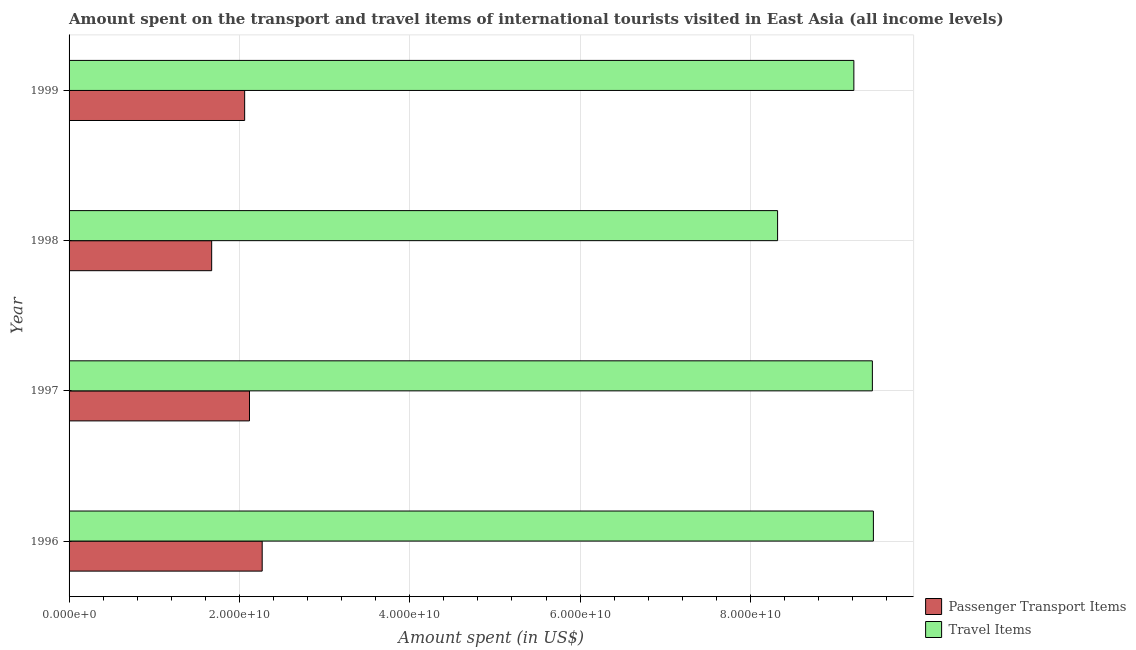How many different coloured bars are there?
Your answer should be compact. 2. How many groups of bars are there?
Make the answer very short. 4. Are the number of bars per tick equal to the number of legend labels?
Provide a succinct answer. Yes. How many bars are there on the 4th tick from the bottom?
Offer a very short reply. 2. What is the amount spent on passenger transport items in 1996?
Offer a very short reply. 2.27e+1. Across all years, what is the maximum amount spent in travel items?
Offer a very short reply. 9.44e+1. Across all years, what is the minimum amount spent in travel items?
Give a very brief answer. 8.32e+1. What is the total amount spent in travel items in the graph?
Provide a short and direct response. 3.64e+11. What is the difference between the amount spent on passenger transport items in 1998 and that in 1999?
Keep it short and to the point. -3.87e+09. What is the difference between the amount spent in travel items in 1998 and the amount spent on passenger transport items in 1997?
Keep it short and to the point. 6.20e+1. What is the average amount spent in travel items per year?
Offer a terse response. 9.10e+1. In the year 1999, what is the difference between the amount spent on passenger transport items and amount spent in travel items?
Provide a succinct answer. -7.15e+1. What is the difference between the highest and the second highest amount spent in travel items?
Provide a short and direct response. 1.20e+08. What is the difference between the highest and the lowest amount spent on passenger transport items?
Give a very brief answer. 5.93e+09. In how many years, is the amount spent on passenger transport items greater than the average amount spent on passenger transport items taken over all years?
Give a very brief answer. 3. What does the 2nd bar from the top in 1996 represents?
Provide a short and direct response. Passenger Transport Items. What does the 2nd bar from the bottom in 1996 represents?
Your response must be concise. Travel Items. Are all the bars in the graph horizontal?
Provide a short and direct response. Yes. How many years are there in the graph?
Give a very brief answer. 4. What is the difference between two consecutive major ticks on the X-axis?
Provide a succinct answer. 2.00e+1. Are the values on the major ticks of X-axis written in scientific E-notation?
Your response must be concise. Yes. How many legend labels are there?
Offer a terse response. 2. How are the legend labels stacked?
Ensure brevity in your answer.  Vertical. What is the title of the graph?
Ensure brevity in your answer.  Amount spent on the transport and travel items of international tourists visited in East Asia (all income levels). Does "RDB nonconcessional" appear as one of the legend labels in the graph?
Your response must be concise. No. What is the label or title of the X-axis?
Provide a short and direct response. Amount spent (in US$). What is the Amount spent (in US$) in Passenger Transport Items in 1996?
Your answer should be compact. 2.27e+1. What is the Amount spent (in US$) of Travel Items in 1996?
Your answer should be compact. 9.44e+1. What is the Amount spent (in US$) in Passenger Transport Items in 1997?
Make the answer very short. 2.12e+1. What is the Amount spent (in US$) of Travel Items in 1997?
Offer a terse response. 9.43e+1. What is the Amount spent (in US$) in Passenger Transport Items in 1998?
Make the answer very short. 1.67e+1. What is the Amount spent (in US$) of Travel Items in 1998?
Provide a short and direct response. 8.32e+1. What is the Amount spent (in US$) of Passenger Transport Items in 1999?
Make the answer very short. 2.06e+1. What is the Amount spent (in US$) in Travel Items in 1999?
Offer a terse response. 9.21e+1. Across all years, what is the maximum Amount spent (in US$) of Passenger Transport Items?
Keep it short and to the point. 2.27e+1. Across all years, what is the maximum Amount spent (in US$) of Travel Items?
Offer a terse response. 9.44e+1. Across all years, what is the minimum Amount spent (in US$) of Passenger Transport Items?
Offer a terse response. 1.67e+1. Across all years, what is the minimum Amount spent (in US$) of Travel Items?
Your answer should be very brief. 8.32e+1. What is the total Amount spent (in US$) in Passenger Transport Items in the graph?
Your answer should be very brief. 8.12e+1. What is the total Amount spent (in US$) of Travel Items in the graph?
Your answer should be very brief. 3.64e+11. What is the difference between the Amount spent (in US$) in Passenger Transport Items in 1996 and that in 1997?
Keep it short and to the point. 1.49e+09. What is the difference between the Amount spent (in US$) of Travel Items in 1996 and that in 1997?
Provide a succinct answer. 1.20e+08. What is the difference between the Amount spent (in US$) in Passenger Transport Items in 1996 and that in 1998?
Offer a very short reply. 5.93e+09. What is the difference between the Amount spent (in US$) in Travel Items in 1996 and that in 1998?
Give a very brief answer. 1.12e+1. What is the difference between the Amount spent (in US$) in Passenger Transport Items in 1996 and that in 1999?
Keep it short and to the point. 2.06e+09. What is the difference between the Amount spent (in US$) of Travel Items in 1996 and that in 1999?
Your response must be concise. 2.29e+09. What is the difference between the Amount spent (in US$) of Passenger Transport Items in 1997 and that in 1998?
Your response must be concise. 4.44e+09. What is the difference between the Amount spent (in US$) of Travel Items in 1997 and that in 1998?
Keep it short and to the point. 1.11e+1. What is the difference between the Amount spent (in US$) of Passenger Transport Items in 1997 and that in 1999?
Provide a short and direct response. 5.68e+08. What is the difference between the Amount spent (in US$) of Travel Items in 1997 and that in 1999?
Ensure brevity in your answer.  2.17e+09. What is the difference between the Amount spent (in US$) of Passenger Transport Items in 1998 and that in 1999?
Give a very brief answer. -3.87e+09. What is the difference between the Amount spent (in US$) of Travel Items in 1998 and that in 1999?
Your response must be concise. -8.95e+09. What is the difference between the Amount spent (in US$) of Passenger Transport Items in 1996 and the Amount spent (in US$) of Travel Items in 1997?
Provide a short and direct response. -7.16e+1. What is the difference between the Amount spent (in US$) in Passenger Transport Items in 1996 and the Amount spent (in US$) in Travel Items in 1998?
Provide a short and direct response. -6.05e+1. What is the difference between the Amount spent (in US$) in Passenger Transport Items in 1996 and the Amount spent (in US$) in Travel Items in 1999?
Your response must be concise. -6.95e+1. What is the difference between the Amount spent (in US$) in Passenger Transport Items in 1997 and the Amount spent (in US$) in Travel Items in 1998?
Provide a succinct answer. -6.20e+1. What is the difference between the Amount spent (in US$) in Passenger Transport Items in 1997 and the Amount spent (in US$) in Travel Items in 1999?
Your answer should be compact. -7.10e+1. What is the difference between the Amount spent (in US$) in Passenger Transport Items in 1998 and the Amount spent (in US$) in Travel Items in 1999?
Your answer should be very brief. -7.54e+1. What is the average Amount spent (in US$) in Passenger Transport Items per year?
Keep it short and to the point. 2.03e+1. What is the average Amount spent (in US$) of Travel Items per year?
Ensure brevity in your answer.  9.10e+1. In the year 1996, what is the difference between the Amount spent (in US$) in Passenger Transport Items and Amount spent (in US$) in Travel Items?
Make the answer very short. -7.18e+1. In the year 1997, what is the difference between the Amount spent (in US$) in Passenger Transport Items and Amount spent (in US$) in Travel Items?
Your response must be concise. -7.31e+1. In the year 1998, what is the difference between the Amount spent (in US$) of Passenger Transport Items and Amount spent (in US$) of Travel Items?
Give a very brief answer. -6.64e+1. In the year 1999, what is the difference between the Amount spent (in US$) of Passenger Transport Items and Amount spent (in US$) of Travel Items?
Offer a terse response. -7.15e+1. What is the ratio of the Amount spent (in US$) of Passenger Transport Items in 1996 to that in 1997?
Provide a short and direct response. 1.07. What is the ratio of the Amount spent (in US$) in Passenger Transport Items in 1996 to that in 1998?
Provide a succinct answer. 1.35. What is the ratio of the Amount spent (in US$) of Travel Items in 1996 to that in 1998?
Give a very brief answer. 1.14. What is the ratio of the Amount spent (in US$) in Passenger Transport Items in 1996 to that in 1999?
Offer a terse response. 1.1. What is the ratio of the Amount spent (in US$) of Travel Items in 1996 to that in 1999?
Your response must be concise. 1.02. What is the ratio of the Amount spent (in US$) of Passenger Transport Items in 1997 to that in 1998?
Give a very brief answer. 1.27. What is the ratio of the Amount spent (in US$) of Travel Items in 1997 to that in 1998?
Offer a terse response. 1.13. What is the ratio of the Amount spent (in US$) of Passenger Transport Items in 1997 to that in 1999?
Your answer should be compact. 1.03. What is the ratio of the Amount spent (in US$) in Travel Items in 1997 to that in 1999?
Your response must be concise. 1.02. What is the ratio of the Amount spent (in US$) of Passenger Transport Items in 1998 to that in 1999?
Offer a terse response. 0.81. What is the ratio of the Amount spent (in US$) of Travel Items in 1998 to that in 1999?
Offer a terse response. 0.9. What is the difference between the highest and the second highest Amount spent (in US$) of Passenger Transport Items?
Ensure brevity in your answer.  1.49e+09. What is the difference between the highest and the second highest Amount spent (in US$) of Travel Items?
Give a very brief answer. 1.20e+08. What is the difference between the highest and the lowest Amount spent (in US$) of Passenger Transport Items?
Make the answer very short. 5.93e+09. What is the difference between the highest and the lowest Amount spent (in US$) of Travel Items?
Give a very brief answer. 1.12e+1. 